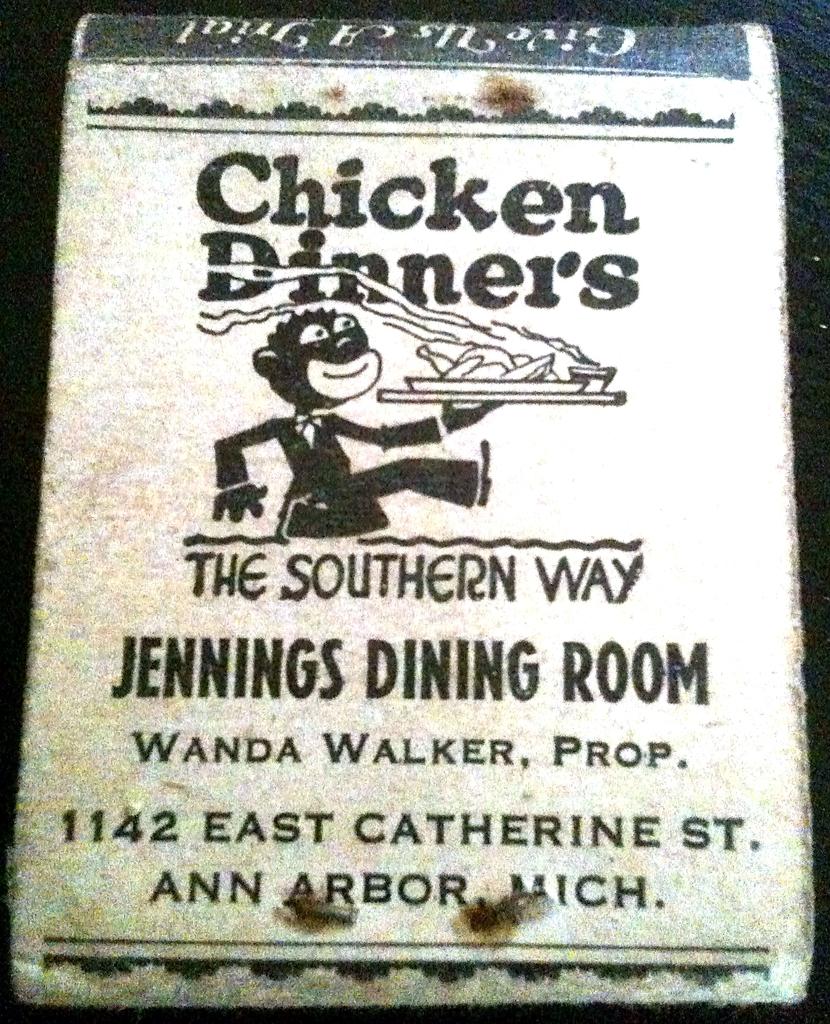What is the address here?
Give a very brief answer. 1142 east catherine st. What is the name of the restaurant?
Your answer should be very brief. Jennings dining room. 